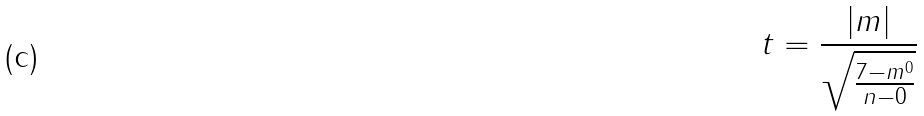Convert formula to latex. <formula><loc_0><loc_0><loc_500><loc_500>t = \frac { | m | } { \sqrt { \frac { 7 - m ^ { 0 } } { n - 0 } } }</formula> 